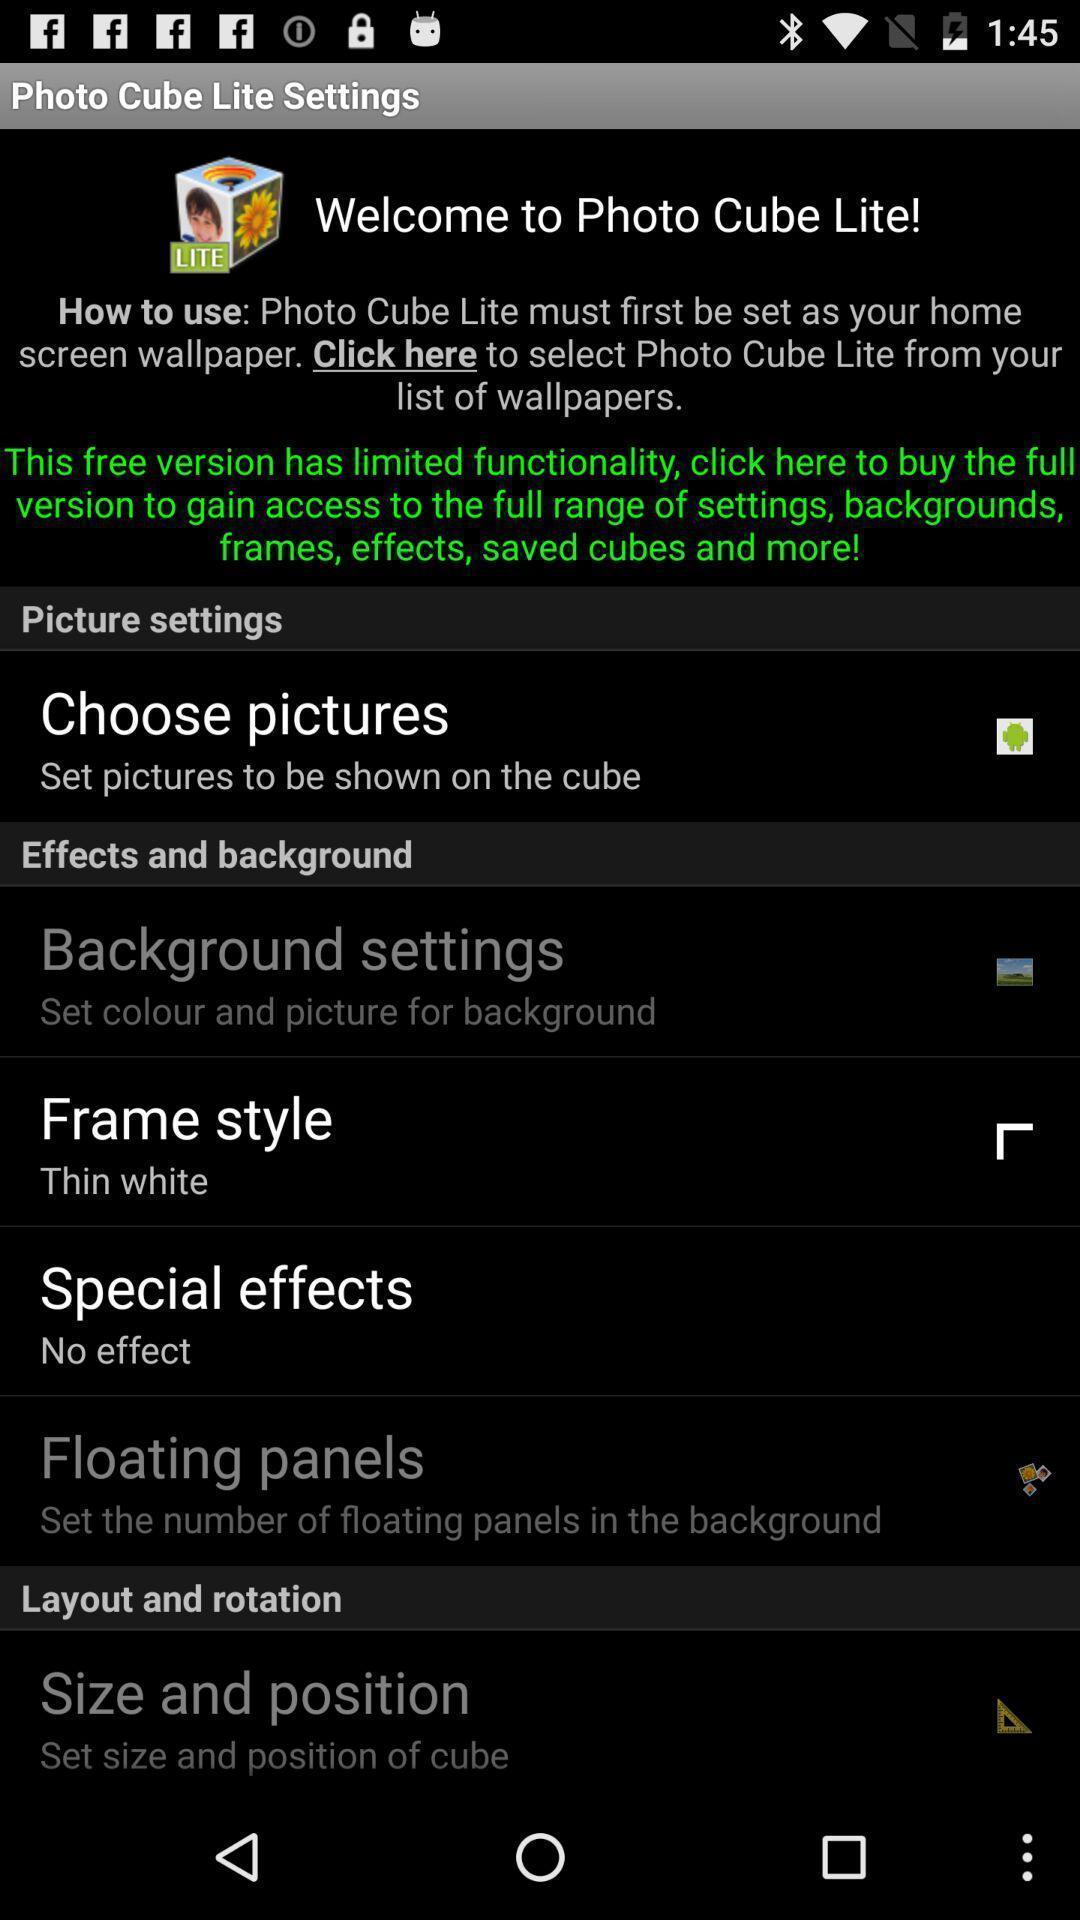Tell me about the visual elements in this screen capture. Welcome page for wallpaper app. 